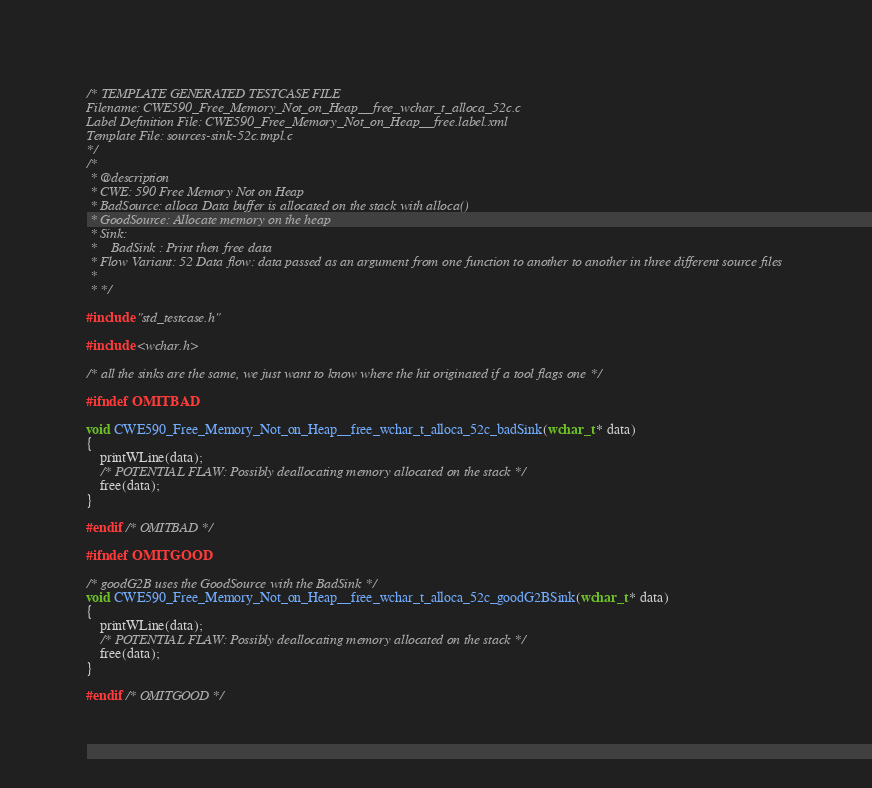Convert code to text. <code><loc_0><loc_0><loc_500><loc_500><_C_>/* TEMPLATE GENERATED TESTCASE FILE
Filename: CWE590_Free_Memory_Not_on_Heap__free_wchar_t_alloca_52c.c
Label Definition File: CWE590_Free_Memory_Not_on_Heap__free.label.xml
Template File: sources-sink-52c.tmpl.c
*/
/*
 * @description
 * CWE: 590 Free Memory Not on Heap
 * BadSource: alloca Data buffer is allocated on the stack with alloca()
 * GoodSource: Allocate memory on the heap
 * Sink:
 *    BadSink : Print then free data
 * Flow Variant: 52 Data flow: data passed as an argument from one function to another to another in three different source files
 *
 * */

#include "std_testcase.h"

#include <wchar.h>

/* all the sinks are the same, we just want to know where the hit originated if a tool flags one */

#ifndef OMITBAD

void CWE590_Free_Memory_Not_on_Heap__free_wchar_t_alloca_52c_badSink(wchar_t * data)
{
    printWLine(data);
    /* POTENTIAL FLAW: Possibly deallocating memory allocated on the stack */
    free(data);
}

#endif /* OMITBAD */

#ifndef OMITGOOD

/* goodG2B uses the GoodSource with the BadSink */
void CWE590_Free_Memory_Not_on_Heap__free_wchar_t_alloca_52c_goodG2BSink(wchar_t * data)
{
    printWLine(data);
    /* POTENTIAL FLAW: Possibly deallocating memory allocated on the stack */
    free(data);
}

#endif /* OMITGOOD */
</code> 